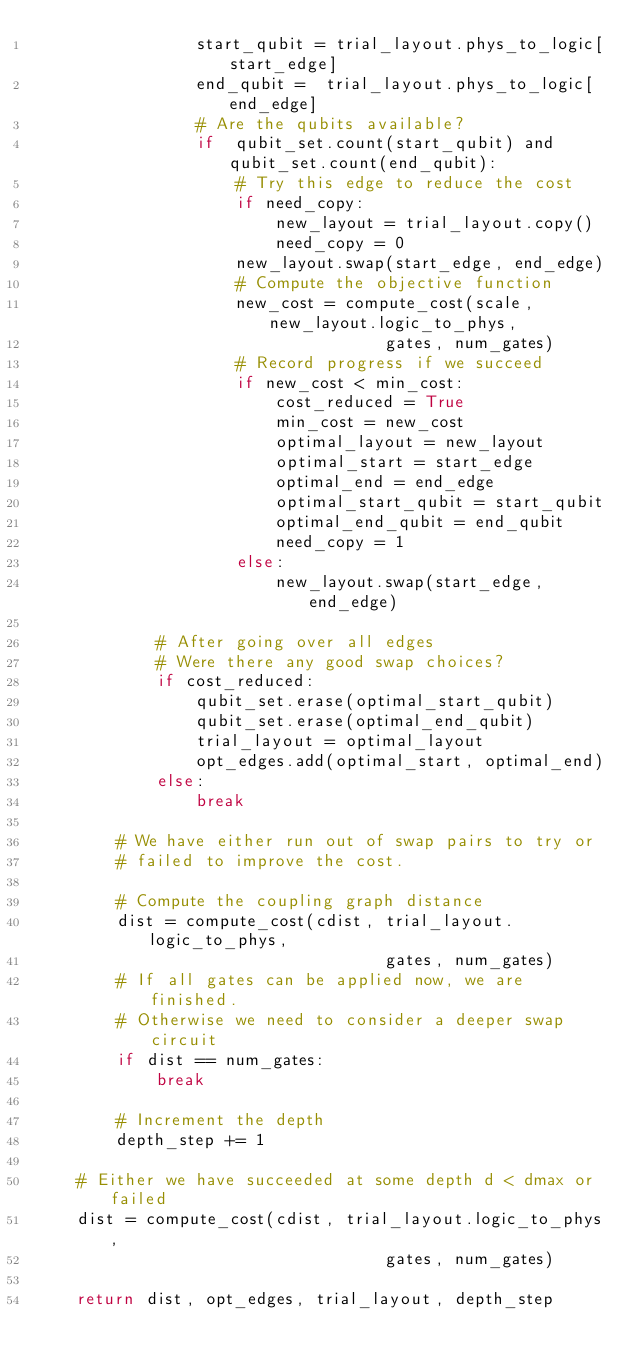<code> <loc_0><loc_0><loc_500><loc_500><_Cython_>                start_qubit = trial_layout.phys_to_logic[start_edge]
                end_qubit =  trial_layout.phys_to_logic[end_edge]
                # Are the qubits available?
                if  qubit_set.count(start_qubit) and qubit_set.count(end_qubit):
                    # Try this edge to reduce the cost
                    if need_copy:
                        new_layout = trial_layout.copy()
                        need_copy = 0
                    new_layout.swap(start_edge, end_edge)
                    # Compute the objective function
                    new_cost = compute_cost(scale, new_layout.logic_to_phys,
                                   gates, num_gates)
                    # Record progress if we succeed
                    if new_cost < min_cost:
                        cost_reduced = True
                        min_cost = new_cost
                        optimal_layout = new_layout
                        optimal_start = start_edge
                        optimal_end = end_edge
                        optimal_start_qubit = start_qubit
                        optimal_end_qubit = end_qubit
                        need_copy = 1
                    else:
                        new_layout.swap(start_edge, end_edge)

            # After going over all edges
            # Were there any good swap choices?
            if cost_reduced:
                qubit_set.erase(optimal_start_qubit)
                qubit_set.erase(optimal_end_qubit)
                trial_layout = optimal_layout
                opt_edges.add(optimal_start, optimal_end)
            else:
                break

        # We have either run out of swap pairs to try or
        # failed to improve the cost.

        # Compute the coupling graph distance
        dist = compute_cost(cdist, trial_layout.logic_to_phys,
                                   gates, num_gates)
        # If all gates can be applied now, we are finished.
        # Otherwise we need to consider a deeper swap circuit
        if dist == num_gates:
            break

        # Increment the depth
        depth_step += 1

    # Either we have succeeded at some depth d < dmax or failed
    dist = compute_cost(cdist, trial_layout.logic_to_phys,
                                   gates, num_gates)
    
    return dist, opt_edges, trial_layout, depth_step
</code> 